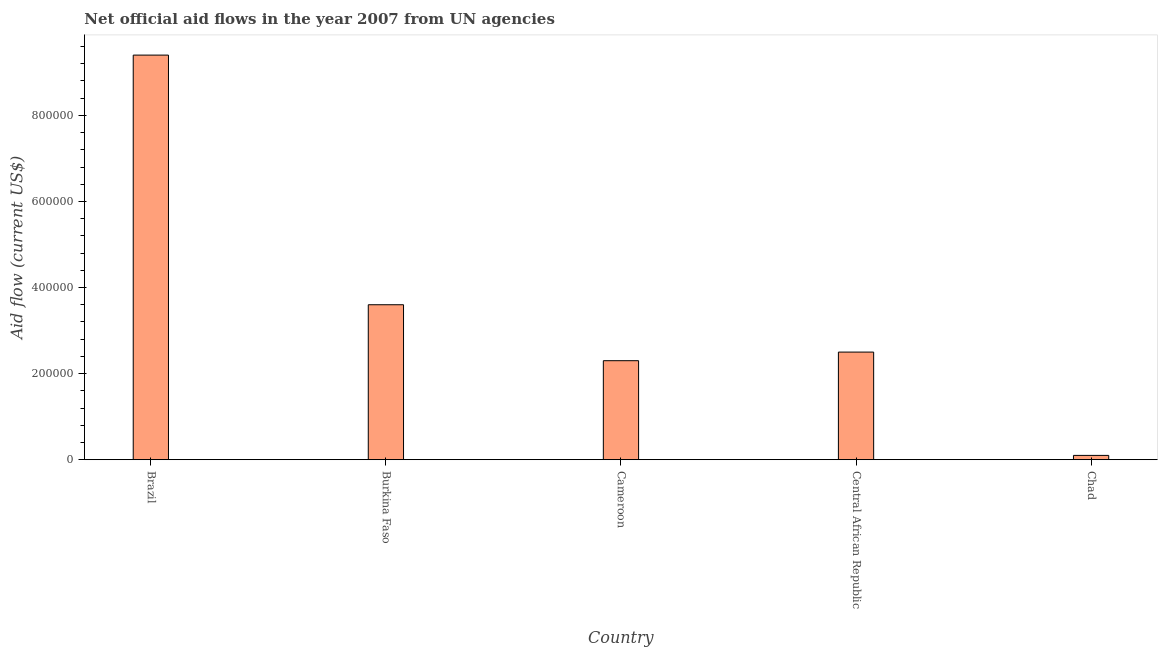Does the graph contain grids?
Make the answer very short. No. What is the title of the graph?
Keep it short and to the point. Net official aid flows in the year 2007 from UN agencies. What is the label or title of the Y-axis?
Your answer should be very brief. Aid flow (current US$). Across all countries, what is the maximum net official flows from un agencies?
Offer a terse response. 9.40e+05. Across all countries, what is the minimum net official flows from un agencies?
Ensure brevity in your answer.  10000. In which country was the net official flows from un agencies minimum?
Make the answer very short. Chad. What is the sum of the net official flows from un agencies?
Provide a succinct answer. 1.79e+06. What is the average net official flows from un agencies per country?
Offer a very short reply. 3.58e+05. In how many countries, is the net official flows from un agencies greater than 240000 US$?
Offer a terse response. 3. What is the ratio of the net official flows from un agencies in Cameroon to that in Chad?
Provide a short and direct response. 23. Is the net official flows from un agencies in Cameroon less than that in Chad?
Ensure brevity in your answer.  No. Is the difference between the net official flows from un agencies in Burkina Faso and Chad greater than the difference between any two countries?
Offer a very short reply. No. What is the difference between the highest and the second highest net official flows from un agencies?
Offer a very short reply. 5.80e+05. Is the sum of the net official flows from un agencies in Brazil and Burkina Faso greater than the maximum net official flows from un agencies across all countries?
Offer a terse response. Yes. What is the difference between the highest and the lowest net official flows from un agencies?
Provide a succinct answer. 9.30e+05. How many bars are there?
Make the answer very short. 5. What is the Aid flow (current US$) of Brazil?
Make the answer very short. 9.40e+05. What is the Aid flow (current US$) in Cameroon?
Your response must be concise. 2.30e+05. What is the Aid flow (current US$) in Central African Republic?
Offer a very short reply. 2.50e+05. What is the Aid flow (current US$) in Chad?
Provide a succinct answer. 10000. What is the difference between the Aid flow (current US$) in Brazil and Burkina Faso?
Your answer should be very brief. 5.80e+05. What is the difference between the Aid flow (current US$) in Brazil and Cameroon?
Your response must be concise. 7.10e+05. What is the difference between the Aid flow (current US$) in Brazil and Central African Republic?
Make the answer very short. 6.90e+05. What is the difference between the Aid flow (current US$) in Brazil and Chad?
Your response must be concise. 9.30e+05. What is the difference between the Aid flow (current US$) in Burkina Faso and Cameroon?
Provide a succinct answer. 1.30e+05. What is the difference between the Aid flow (current US$) in Cameroon and Central African Republic?
Your answer should be very brief. -2.00e+04. What is the difference between the Aid flow (current US$) in Cameroon and Chad?
Give a very brief answer. 2.20e+05. What is the ratio of the Aid flow (current US$) in Brazil to that in Burkina Faso?
Keep it short and to the point. 2.61. What is the ratio of the Aid flow (current US$) in Brazil to that in Cameroon?
Offer a terse response. 4.09. What is the ratio of the Aid flow (current US$) in Brazil to that in Central African Republic?
Keep it short and to the point. 3.76. What is the ratio of the Aid flow (current US$) in Brazil to that in Chad?
Provide a short and direct response. 94. What is the ratio of the Aid flow (current US$) in Burkina Faso to that in Cameroon?
Your answer should be very brief. 1.56. What is the ratio of the Aid flow (current US$) in Burkina Faso to that in Central African Republic?
Offer a very short reply. 1.44. What is the ratio of the Aid flow (current US$) in Burkina Faso to that in Chad?
Provide a succinct answer. 36. What is the ratio of the Aid flow (current US$) in Cameroon to that in Central African Republic?
Provide a short and direct response. 0.92. What is the ratio of the Aid flow (current US$) in Cameroon to that in Chad?
Your response must be concise. 23. 